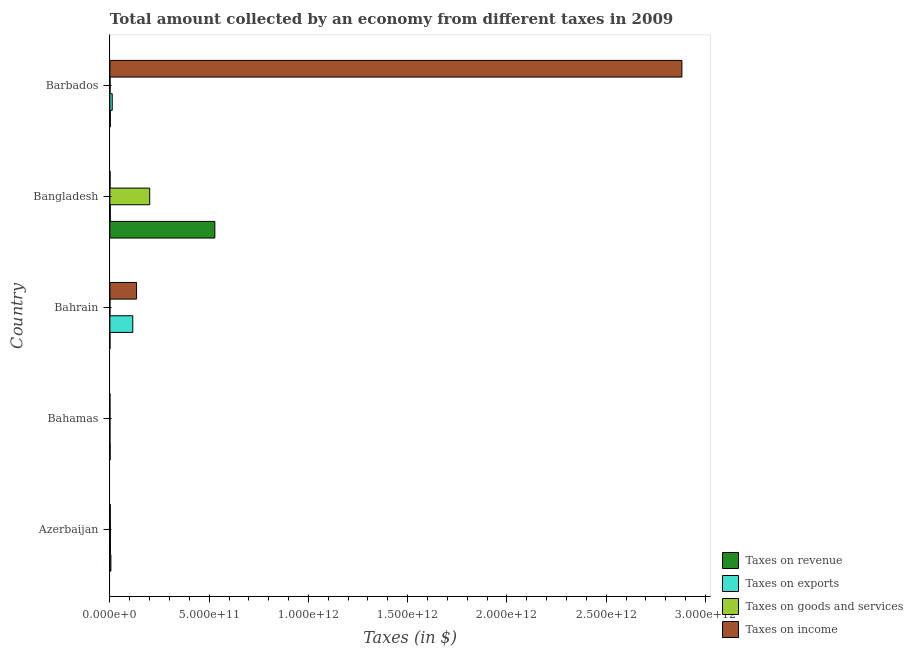Are the number of bars per tick equal to the number of legend labels?
Your answer should be very brief. Yes. What is the label of the 5th group of bars from the top?
Ensure brevity in your answer.  Azerbaijan. What is the amount collected as tax on revenue in Barbados?
Give a very brief answer. 2.21e+09. Across all countries, what is the maximum amount collected as tax on goods?
Your response must be concise. 2.01e+11. Across all countries, what is the minimum amount collected as tax on goods?
Provide a short and direct response. 2.07e+07. In which country was the amount collected as tax on income maximum?
Make the answer very short. Barbados. In which country was the amount collected as tax on exports minimum?
Your answer should be very brief. Bahamas. What is the total amount collected as tax on revenue in the graph?
Offer a very short reply. 5.37e+11. What is the difference between the amount collected as tax on exports in Bangladesh and that in Barbados?
Ensure brevity in your answer.  -9.80e+09. What is the difference between the amount collected as tax on revenue in Bahrain and the amount collected as tax on income in Barbados?
Your answer should be compact. -2.88e+12. What is the average amount collected as tax on exports per country?
Keep it short and to the point. 2.64e+1. What is the difference between the amount collected as tax on goods and amount collected as tax on revenue in Bahamas?
Provide a succinct answer. -9.43e+08. In how many countries, is the amount collected as tax on exports greater than 200000000000 $?
Provide a succinct answer. 0. What is the ratio of the amount collected as tax on exports in Bahrain to that in Barbados?
Offer a terse response. 9.75. What is the difference between the highest and the second highest amount collected as tax on revenue?
Give a very brief answer. 5.24e+11. What is the difference between the highest and the lowest amount collected as tax on revenue?
Ensure brevity in your answer.  5.29e+11. In how many countries, is the amount collected as tax on goods greater than the average amount collected as tax on goods taken over all countries?
Provide a short and direct response. 1. Is the sum of the amount collected as tax on income in Azerbaijan and Barbados greater than the maximum amount collected as tax on goods across all countries?
Offer a very short reply. Yes. What does the 2nd bar from the top in Bangladesh represents?
Make the answer very short. Taxes on goods and services. What does the 4th bar from the bottom in Barbados represents?
Your answer should be compact. Taxes on income. How many bars are there?
Provide a short and direct response. 20. Are all the bars in the graph horizontal?
Your response must be concise. Yes. What is the difference between two consecutive major ticks on the X-axis?
Your answer should be very brief. 5.00e+11. Where does the legend appear in the graph?
Your response must be concise. Bottom right. What is the title of the graph?
Provide a succinct answer. Total amount collected by an economy from different taxes in 2009. Does "Fish species" appear as one of the legend labels in the graph?
Your answer should be very brief. No. What is the label or title of the X-axis?
Ensure brevity in your answer.  Taxes (in $). What is the Taxes (in $) of Taxes on revenue in Azerbaijan?
Provide a short and direct response. 5.02e+09. What is the Taxes (in $) in Taxes on exports in Azerbaijan?
Provide a succinct answer. 2.72e+09. What is the Taxes (in $) in Taxes on goods and services in Azerbaijan?
Offer a very short reply. 2.59e+09. What is the Taxes (in $) in Taxes on income in Azerbaijan?
Provide a succinct answer. 1.92e+09. What is the Taxes (in $) of Taxes on revenue in Bahamas?
Provide a short and direct response. 1.12e+09. What is the Taxes (in $) in Taxes on exports in Bahamas?
Give a very brief answer. 7.10e+05. What is the Taxes (in $) in Taxes on goods and services in Bahamas?
Ensure brevity in your answer.  1.80e+08. What is the Taxes (in $) of Taxes on income in Bahamas?
Keep it short and to the point. 1.12e+07. What is the Taxes (in $) in Taxes on revenue in Bahrain?
Offer a very short reply. 1.18e+08. What is the Taxes (in $) in Taxes on exports in Bahrain?
Make the answer very short. 1.15e+11. What is the Taxes (in $) in Taxes on goods and services in Bahrain?
Your response must be concise. 2.07e+07. What is the Taxes (in $) in Taxes on income in Bahrain?
Make the answer very short. 1.34e+11. What is the Taxes (in $) of Taxes on revenue in Bangladesh?
Provide a succinct answer. 5.29e+11. What is the Taxes (in $) of Taxes on exports in Bangladesh?
Provide a succinct answer. 2.03e+09. What is the Taxes (in $) of Taxes on goods and services in Bangladesh?
Offer a very short reply. 2.01e+11. What is the Taxes (in $) in Taxes on income in Bangladesh?
Offer a very short reply. 8.17e+08. What is the Taxes (in $) of Taxes on revenue in Barbados?
Your response must be concise. 2.21e+09. What is the Taxes (in $) of Taxes on exports in Barbados?
Offer a very short reply. 1.18e+1. What is the Taxes (in $) in Taxes on goods and services in Barbados?
Keep it short and to the point. 9.86e+08. What is the Taxes (in $) in Taxes on income in Barbados?
Make the answer very short. 2.88e+12. Across all countries, what is the maximum Taxes (in $) in Taxes on revenue?
Your answer should be compact. 5.29e+11. Across all countries, what is the maximum Taxes (in $) in Taxes on exports?
Provide a succinct answer. 1.15e+11. Across all countries, what is the maximum Taxes (in $) of Taxes on goods and services?
Offer a terse response. 2.01e+11. Across all countries, what is the maximum Taxes (in $) in Taxes on income?
Your response must be concise. 2.88e+12. Across all countries, what is the minimum Taxes (in $) in Taxes on revenue?
Offer a very short reply. 1.18e+08. Across all countries, what is the minimum Taxes (in $) of Taxes on exports?
Offer a terse response. 7.10e+05. Across all countries, what is the minimum Taxes (in $) of Taxes on goods and services?
Offer a very short reply. 2.07e+07. Across all countries, what is the minimum Taxes (in $) in Taxes on income?
Your response must be concise. 1.12e+07. What is the total Taxes (in $) of Taxes on revenue in the graph?
Give a very brief answer. 5.37e+11. What is the total Taxes (in $) in Taxes on exports in the graph?
Provide a succinct answer. 1.32e+11. What is the total Taxes (in $) of Taxes on goods and services in the graph?
Provide a short and direct response. 2.04e+11. What is the total Taxes (in $) in Taxes on income in the graph?
Your answer should be compact. 3.02e+12. What is the difference between the Taxes (in $) of Taxes on revenue in Azerbaijan and that in Bahamas?
Give a very brief answer. 3.90e+09. What is the difference between the Taxes (in $) in Taxes on exports in Azerbaijan and that in Bahamas?
Make the answer very short. 2.72e+09. What is the difference between the Taxes (in $) in Taxes on goods and services in Azerbaijan and that in Bahamas?
Provide a short and direct response. 2.41e+09. What is the difference between the Taxes (in $) in Taxes on income in Azerbaijan and that in Bahamas?
Your answer should be very brief. 1.91e+09. What is the difference between the Taxes (in $) of Taxes on revenue in Azerbaijan and that in Bahrain?
Keep it short and to the point. 4.90e+09. What is the difference between the Taxes (in $) in Taxes on exports in Azerbaijan and that in Bahrain?
Your answer should be very brief. -1.13e+11. What is the difference between the Taxes (in $) of Taxes on goods and services in Azerbaijan and that in Bahrain?
Your answer should be compact. 2.57e+09. What is the difference between the Taxes (in $) of Taxes on income in Azerbaijan and that in Bahrain?
Offer a terse response. -1.32e+11. What is the difference between the Taxes (in $) of Taxes on revenue in Azerbaijan and that in Bangladesh?
Offer a very short reply. -5.24e+11. What is the difference between the Taxes (in $) in Taxes on exports in Azerbaijan and that in Bangladesh?
Offer a terse response. 6.92e+08. What is the difference between the Taxes (in $) of Taxes on goods and services in Azerbaijan and that in Bangladesh?
Give a very brief answer. -1.98e+11. What is the difference between the Taxes (in $) in Taxes on income in Azerbaijan and that in Bangladesh?
Your response must be concise. 1.10e+09. What is the difference between the Taxes (in $) in Taxes on revenue in Azerbaijan and that in Barbados?
Provide a succinct answer. 2.81e+09. What is the difference between the Taxes (in $) in Taxes on exports in Azerbaijan and that in Barbados?
Your answer should be very brief. -9.11e+09. What is the difference between the Taxes (in $) in Taxes on goods and services in Azerbaijan and that in Barbados?
Ensure brevity in your answer.  1.61e+09. What is the difference between the Taxes (in $) in Taxes on income in Azerbaijan and that in Barbados?
Provide a short and direct response. -2.88e+12. What is the difference between the Taxes (in $) of Taxes on revenue in Bahamas and that in Bahrain?
Your response must be concise. 1.01e+09. What is the difference between the Taxes (in $) of Taxes on exports in Bahamas and that in Bahrain?
Make the answer very short. -1.15e+11. What is the difference between the Taxes (in $) in Taxes on goods and services in Bahamas and that in Bahrain?
Ensure brevity in your answer.  1.60e+08. What is the difference between the Taxes (in $) of Taxes on income in Bahamas and that in Bahrain?
Keep it short and to the point. -1.34e+11. What is the difference between the Taxes (in $) of Taxes on revenue in Bahamas and that in Bangladesh?
Provide a succinct answer. -5.28e+11. What is the difference between the Taxes (in $) of Taxes on exports in Bahamas and that in Bangladesh?
Your answer should be compact. -2.03e+09. What is the difference between the Taxes (in $) of Taxes on goods and services in Bahamas and that in Bangladesh?
Ensure brevity in your answer.  -2.00e+11. What is the difference between the Taxes (in $) of Taxes on income in Bahamas and that in Bangladesh?
Offer a very short reply. -8.06e+08. What is the difference between the Taxes (in $) of Taxes on revenue in Bahamas and that in Barbados?
Your answer should be very brief. -1.08e+09. What is the difference between the Taxes (in $) of Taxes on exports in Bahamas and that in Barbados?
Provide a succinct answer. -1.18e+1. What is the difference between the Taxes (in $) in Taxes on goods and services in Bahamas and that in Barbados?
Give a very brief answer. -8.06e+08. What is the difference between the Taxes (in $) of Taxes on income in Bahamas and that in Barbados?
Your answer should be compact. -2.88e+12. What is the difference between the Taxes (in $) in Taxes on revenue in Bahrain and that in Bangladesh?
Offer a terse response. -5.29e+11. What is the difference between the Taxes (in $) of Taxes on exports in Bahrain and that in Bangladesh?
Your response must be concise. 1.13e+11. What is the difference between the Taxes (in $) of Taxes on goods and services in Bahrain and that in Bangladesh?
Make the answer very short. -2.01e+11. What is the difference between the Taxes (in $) of Taxes on income in Bahrain and that in Bangladesh?
Give a very brief answer. 1.34e+11. What is the difference between the Taxes (in $) in Taxes on revenue in Bahrain and that in Barbados?
Make the answer very short. -2.09e+09. What is the difference between the Taxes (in $) in Taxes on exports in Bahrain and that in Barbados?
Keep it short and to the point. 1.03e+11. What is the difference between the Taxes (in $) in Taxes on goods and services in Bahrain and that in Barbados?
Your response must be concise. -9.66e+08. What is the difference between the Taxes (in $) in Taxes on income in Bahrain and that in Barbados?
Keep it short and to the point. -2.75e+12. What is the difference between the Taxes (in $) in Taxes on revenue in Bangladesh and that in Barbados?
Your answer should be very brief. 5.26e+11. What is the difference between the Taxes (in $) in Taxes on exports in Bangladesh and that in Barbados?
Provide a short and direct response. -9.80e+09. What is the difference between the Taxes (in $) of Taxes on goods and services in Bangladesh and that in Barbados?
Make the answer very short. 2.00e+11. What is the difference between the Taxes (in $) of Taxes on income in Bangladesh and that in Barbados?
Your response must be concise. -2.88e+12. What is the difference between the Taxes (in $) of Taxes on revenue in Azerbaijan and the Taxes (in $) of Taxes on exports in Bahamas?
Make the answer very short. 5.02e+09. What is the difference between the Taxes (in $) of Taxes on revenue in Azerbaijan and the Taxes (in $) of Taxes on goods and services in Bahamas?
Offer a terse response. 4.84e+09. What is the difference between the Taxes (in $) of Taxes on revenue in Azerbaijan and the Taxes (in $) of Taxes on income in Bahamas?
Offer a terse response. 5.01e+09. What is the difference between the Taxes (in $) of Taxes on exports in Azerbaijan and the Taxes (in $) of Taxes on goods and services in Bahamas?
Provide a succinct answer. 2.54e+09. What is the difference between the Taxes (in $) of Taxes on exports in Azerbaijan and the Taxes (in $) of Taxes on income in Bahamas?
Make the answer very short. 2.71e+09. What is the difference between the Taxes (in $) in Taxes on goods and services in Azerbaijan and the Taxes (in $) in Taxes on income in Bahamas?
Ensure brevity in your answer.  2.58e+09. What is the difference between the Taxes (in $) of Taxes on revenue in Azerbaijan and the Taxes (in $) of Taxes on exports in Bahrain?
Your response must be concise. -1.10e+11. What is the difference between the Taxes (in $) of Taxes on revenue in Azerbaijan and the Taxes (in $) of Taxes on goods and services in Bahrain?
Offer a terse response. 5.00e+09. What is the difference between the Taxes (in $) in Taxes on revenue in Azerbaijan and the Taxes (in $) in Taxes on income in Bahrain?
Your answer should be compact. -1.29e+11. What is the difference between the Taxes (in $) of Taxes on exports in Azerbaijan and the Taxes (in $) of Taxes on goods and services in Bahrain?
Your answer should be compact. 2.70e+09. What is the difference between the Taxes (in $) in Taxes on exports in Azerbaijan and the Taxes (in $) in Taxes on income in Bahrain?
Your response must be concise. -1.32e+11. What is the difference between the Taxes (in $) in Taxes on goods and services in Azerbaijan and the Taxes (in $) in Taxes on income in Bahrain?
Your answer should be compact. -1.32e+11. What is the difference between the Taxes (in $) of Taxes on revenue in Azerbaijan and the Taxes (in $) of Taxes on exports in Bangladesh?
Provide a short and direct response. 2.99e+09. What is the difference between the Taxes (in $) of Taxes on revenue in Azerbaijan and the Taxes (in $) of Taxes on goods and services in Bangladesh?
Provide a succinct answer. -1.96e+11. What is the difference between the Taxes (in $) of Taxes on revenue in Azerbaijan and the Taxes (in $) of Taxes on income in Bangladesh?
Provide a short and direct response. 4.21e+09. What is the difference between the Taxes (in $) of Taxes on exports in Azerbaijan and the Taxes (in $) of Taxes on goods and services in Bangladesh?
Provide a short and direct response. -1.98e+11. What is the difference between the Taxes (in $) in Taxes on exports in Azerbaijan and the Taxes (in $) in Taxes on income in Bangladesh?
Provide a short and direct response. 1.91e+09. What is the difference between the Taxes (in $) in Taxes on goods and services in Azerbaijan and the Taxes (in $) in Taxes on income in Bangladesh?
Provide a succinct answer. 1.78e+09. What is the difference between the Taxes (in $) in Taxes on revenue in Azerbaijan and the Taxes (in $) in Taxes on exports in Barbados?
Provide a short and direct response. -6.81e+09. What is the difference between the Taxes (in $) in Taxes on revenue in Azerbaijan and the Taxes (in $) in Taxes on goods and services in Barbados?
Provide a short and direct response. 4.04e+09. What is the difference between the Taxes (in $) of Taxes on revenue in Azerbaijan and the Taxes (in $) of Taxes on income in Barbados?
Make the answer very short. -2.88e+12. What is the difference between the Taxes (in $) in Taxes on exports in Azerbaijan and the Taxes (in $) in Taxes on goods and services in Barbados?
Provide a succinct answer. 1.74e+09. What is the difference between the Taxes (in $) of Taxes on exports in Azerbaijan and the Taxes (in $) of Taxes on income in Barbados?
Your answer should be very brief. -2.88e+12. What is the difference between the Taxes (in $) in Taxes on goods and services in Azerbaijan and the Taxes (in $) in Taxes on income in Barbados?
Make the answer very short. -2.88e+12. What is the difference between the Taxes (in $) of Taxes on revenue in Bahamas and the Taxes (in $) of Taxes on exports in Bahrain?
Give a very brief answer. -1.14e+11. What is the difference between the Taxes (in $) of Taxes on revenue in Bahamas and the Taxes (in $) of Taxes on goods and services in Bahrain?
Your response must be concise. 1.10e+09. What is the difference between the Taxes (in $) in Taxes on revenue in Bahamas and the Taxes (in $) in Taxes on income in Bahrain?
Give a very brief answer. -1.33e+11. What is the difference between the Taxes (in $) in Taxes on exports in Bahamas and the Taxes (in $) in Taxes on goods and services in Bahrain?
Offer a terse response. -2.00e+07. What is the difference between the Taxes (in $) in Taxes on exports in Bahamas and the Taxes (in $) in Taxes on income in Bahrain?
Your answer should be very brief. -1.34e+11. What is the difference between the Taxes (in $) of Taxes on goods and services in Bahamas and the Taxes (in $) of Taxes on income in Bahrain?
Offer a terse response. -1.34e+11. What is the difference between the Taxes (in $) in Taxes on revenue in Bahamas and the Taxes (in $) in Taxes on exports in Bangladesh?
Offer a very short reply. -9.07e+08. What is the difference between the Taxes (in $) in Taxes on revenue in Bahamas and the Taxes (in $) in Taxes on goods and services in Bangladesh?
Provide a succinct answer. -1.99e+11. What is the difference between the Taxes (in $) in Taxes on revenue in Bahamas and the Taxes (in $) in Taxes on income in Bangladesh?
Your answer should be compact. 3.06e+08. What is the difference between the Taxes (in $) in Taxes on exports in Bahamas and the Taxes (in $) in Taxes on goods and services in Bangladesh?
Offer a very short reply. -2.01e+11. What is the difference between the Taxes (in $) in Taxes on exports in Bahamas and the Taxes (in $) in Taxes on income in Bangladesh?
Give a very brief answer. -8.16e+08. What is the difference between the Taxes (in $) of Taxes on goods and services in Bahamas and the Taxes (in $) of Taxes on income in Bangladesh?
Your answer should be compact. -6.36e+08. What is the difference between the Taxes (in $) in Taxes on revenue in Bahamas and the Taxes (in $) in Taxes on exports in Barbados?
Keep it short and to the point. -1.07e+1. What is the difference between the Taxes (in $) in Taxes on revenue in Bahamas and the Taxes (in $) in Taxes on goods and services in Barbados?
Your response must be concise. 1.37e+08. What is the difference between the Taxes (in $) in Taxes on revenue in Bahamas and the Taxes (in $) in Taxes on income in Barbados?
Your answer should be compact. -2.88e+12. What is the difference between the Taxes (in $) of Taxes on exports in Bahamas and the Taxes (in $) of Taxes on goods and services in Barbados?
Provide a succinct answer. -9.86e+08. What is the difference between the Taxes (in $) in Taxes on exports in Bahamas and the Taxes (in $) in Taxes on income in Barbados?
Ensure brevity in your answer.  -2.88e+12. What is the difference between the Taxes (in $) in Taxes on goods and services in Bahamas and the Taxes (in $) in Taxes on income in Barbados?
Your answer should be very brief. -2.88e+12. What is the difference between the Taxes (in $) in Taxes on revenue in Bahrain and the Taxes (in $) in Taxes on exports in Bangladesh?
Keep it short and to the point. -1.91e+09. What is the difference between the Taxes (in $) in Taxes on revenue in Bahrain and the Taxes (in $) in Taxes on goods and services in Bangladesh?
Offer a very short reply. -2.00e+11. What is the difference between the Taxes (in $) of Taxes on revenue in Bahrain and the Taxes (in $) of Taxes on income in Bangladesh?
Provide a short and direct response. -6.99e+08. What is the difference between the Taxes (in $) of Taxes on exports in Bahrain and the Taxes (in $) of Taxes on goods and services in Bangladesh?
Your response must be concise. -8.52e+1. What is the difference between the Taxes (in $) of Taxes on exports in Bahrain and the Taxes (in $) of Taxes on income in Bangladesh?
Your answer should be very brief. 1.15e+11. What is the difference between the Taxes (in $) of Taxes on goods and services in Bahrain and the Taxes (in $) of Taxes on income in Bangladesh?
Your answer should be compact. -7.96e+08. What is the difference between the Taxes (in $) in Taxes on revenue in Bahrain and the Taxes (in $) in Taxes on exports in Barbados?
Make the answer very short. -1.17e+1. What is the difference between the Taxes (in $) of Taxes on revenue in Bahrain and the Taxes (in $) of Taxes on goods and services in Barbados?
Your answer should be compact. -8.69e+08. What is the difference between the Taxes (in $) in Taxes on revenue in Bahrain and the Taxes (in $) in Taxes on income in Barbados?
Offer a terse response. -2.88e+12. What is the difference between the Taxes (in $) in Taxes on exports in Bahrain and the Taxes (in $) in Taxes on goods and services in Barbados?
Your answer should be compact. 1.14e+11. What is the difference between the Taxes (in $) of Taxes on exports in Bahrain and the Taxes (in $) of Taxes on income in Barbados?
Keep it short and to the point. -2.77e+12. What is the difference between the Taxes (in $) in Taxes on goods and services in Bahrain and the Taxes (in $) in Taxes on income in Barbados?
Ensure brevity in your answer.  -2.88e+12. What is the difference between the Taxes (in $) of Taxes on revenue in Bangladesh and the Taxes (in $) of Taxes on exports in Barbados?
Make the answer very short. 5.17e+11. What is the difference between the Taxes (in $) of Taxes on revenue in Bangladesh and the Taxes (in $) of Taxes on goods and services in Barbados?
Your answer should be very brief. 5.28e+11. What is the difference between the Taxes (in $) of Taxes on revenue in Bangladesh and the Taxes (in $) of Taxes on income in Barbados?
Provide a succinct answer. -2.35e+12. What is the difference between the Taxes (in $) in Taxes on exports in Bangladesh and the Taxes (in $) in Taxes on goods and services in Barbados?
Ensure brevity in your answer.  1.04e+09. What is the difference between the Taxes (in $) in Taxes on exports in Bangladesh and the Taxes (in $) in Taxes on income in Barbados?
Your answer should be compact. -2.88e+12. What is the difference between the Taxes (in $) of Taxes on goods and services in Bangladesh and the Taxes (in $) of Taxes on income in Barbados?
Provide a succinct answer. -2.68e+12. What is the average Taxes (in $) in Taxes on revenue per country?
Give a very brief answer. 1.07e+11. What is the average Taxes (in $) of Taxes on exports per country?
Give a very brief answer. 2.64e+1. What is the average Taxes (in $) of Taxes on goods and services per country?
Provide a short and direct response. 4.09e+1. What is the average Taxes (in $) in Taxes on income per country?
Make the answer very short. 6.04e+11. What is the difference between the Taxes (in $) of Taxes on revenue and Taxes (in $) of Taxes on exports in Azerbaijan?
Give a very brief answer. 2.30e+09. What is the difference between the Taxes (in $) of Taxes on revenue and Taxes (in $) of Taxes on goods and services in Azerbaijan?
Your answer should be very brief. 2.43e+09. What is the difference between the Taxes (in $) in Taxes on revenue and Taxes (in $) in Taxes on income in Azerbaijan?
Your answer should be compact. 3.10e+09. What is the difference between the Taxes (in $) of Taxes on exports and Taxes (in $) of Taxes on goods and services in Azerbaijan?
Ensure brevity in your answer.  1.29e+08. What is the difference between the Taxes (in $) of Taxes on exports and Taxes (in $) of Taxes on income in Azerbaijan?
Offer a very short reply. 8.01e+08. What is the difference between the Taxes (in $) in Taxes on goods and services and Taxes (in $) in Taxes on income in Azerbaijan?
Your response must be concise. 6.72e+08. What is the difference between the Taxes (in $) of Taxes on revenue and Taxes (in $) of Taxes on exports in Bahamas?
Offer a very short reply. 1.12e+09. What is the difference between the Taxes (in $) in Taxes on revenue and Taxes (in $) in Taxes on goods and services in Bahamas?
Your answer should be compact. 9.43e+08. What is the difference between the Taxes (in $) in Taxes on revenue and Taxes (in $) in Taxes on income in Bahamas?
Give a very brief answer. 1.11e+09. What is the difference between the Taxes (in $) in Taxes on exports and Taxes (in $) in Taxes on goods and services in Bahamas?
Provide a succinct answer. -1.80e+08. What is the difference between the Taxes (in $) of Taxes on exports and Taxes (in $) of Taxes on income in Bahamas?
Your answer should be very brief. -1.05e+07. What is the difference between the Taxes (in $) in Taxes on goods and services and Taxes (in $) in Taxes on income in Bahamas?
Provide a short and direct response. 1.69e+08. What is the difference between the Taxes (in $) in Taxes on revenue and Taxes (in $) in Taxes on exports in Bahrain?
Offer a terse response. -1.15e+11. What is the difference between the Taxes (in $) in Taxes on revenue and Taxes (in $) in Taxes on goods and services in Bahrain?
Keep it short and to the point. 9.69e+07. What is the difference between the Taxes (in $) of Taxes on revenue and Taxes (in $) of Taxes on income in Bahrain?
Provide a succinct answer. -1.34e+11. What is the difference between the Taxes (in $) in Taxes on exports and Taxes (in $) in Taxes on goods and services in Bahrain?
Keep it short and to the point. 1.15e+11. What is the difference between the Taxes (in $) of Taxes on exports and Taxes (in $) of Taxes on income in Bahrain?
Provide a short and direct response. -1.90e+1. What is the difference between the Taxes (in $) in Taxes on goods and services and Taxes (in $) in Taxes on income in Bahrain?
Provide a short and direct response. -1.34e+11. What is the difference between the Taxes (in $) in Taxes on revenue and Taxes (in $) in Taxes on exports in Bangladesh?
Provide a succinct answer. 5.27e+11. What is the difference between the Taxes (in $) in Taxes on revenue and Taxes (in $) in Taxes on goods and services in Bangladesh?
Offer a terse response. 3.28e+11. What is the difference between the Taxes (in $) of Taxes on revenue and Taxes (in $) of Taxes on income in Bangladesh?
Provide a succinct answer. 5.28e+11. What is the difference between the Taxes (in $) of Taxes on exports and Taxes (in $) of Taxes on goods and services in Bangladesh?
Your response must be concise. -1.99e+11. What is the difference between the Taxes (in $) of Taxes on exports and Taxes (in $) of Taxes on income in Bangladesh?
Make the answer very short. 1.21e+09. What is the difference between the Taxes (in $) of Taxes on goods and services and Taxes (in $) of Taxes on income in Bangladesh?
Offer a terse response. 2.00e+11. What is the difference between the Taxes (in $) of Taxes on revenue and Taxes (in $) of Taxes on exports in Barbados?
Offer a terse response. -9.63e+09. What is the difference between the Taxes (in $) in Taxes on revenue and Taxes (in $) in Taxes on goods and services in Barbados?
Your answer should be very brief. 1.22e+09. What is the difference between the Taxes (in $) in Taxes on revenue and Taxes (in $) in Taxes on income in Barbados?
Give a very brief answer. -2.88e+12. What is the difference between the Taxes (in $) in Taxes on exports and Taxes (in $) in Taxes on goods and services in Barbados?
Offer a very short reply. 1.08e+1. What is the difference between the Taxes (in $) of Taxes on exports and Taxes (in $) of Taxes on income in Barbados?
Give a very brief answer. -2.87e+12. What is the difference between the Taxes (in $) of Taxes on goods and services and Taxes (in $) of Taxes on income in Barbados?
Offer a very short reply. -2.88e+12. What is the ratio of the Taxes (in $) of Taxes on revenue in Azerbaijan to that in Bahamas?
Your response must be concise. 4.47. What is the ratio of the Taxes (in $) in Taxes on exports in Azerbaijan to that in Bahamas?
Give a very brief answer. 3833.75. What is the ratio of the Taxes (in $) in Taxes on goods and services in Azerbaijan to that in Bahamas?
Give a very brief answer. 14.37. What is the ratio of the Taxes (in $) of Taxes on income in Azerbaijan to that in Bahamas?
Offer a terse response. 171.78. What is the ratio of the Taxes (in $) in Taxes on revenue in Azerbaijan to that in Bahrain?
Offer a very short reply. 42.72. What is the ratio of the Taxes (in $) in Taxes on exports in Azerbaijan to that in Bahrain?
Keep it short and to the point. 0.02. What is the ratio of the Taxes (in $) in Taxes on goods and services in Azerbaijan to that in Bahrain?
Make the answer very short. 125.27. What is the ratio of the Taxes (in $) in Taxes on income in Azerbaijan to that in Bahrain?
Offer a terse response. 0.01. What is the ratio of the Taxes (in $) of Taxes on revenue in Azerbaijan to that in Bangladesh?
Keep it short and to the point. 0.01. What is the ratio of the Taxes (in $) in Taxes on exports in Azerbaijan to that in Bangladesh?
Your response must be concise. 1.34. What is the ratio of the Taxes (in $) of Taxes on goods and services in Azerbaijan to that in Bangladesh?
Offer a very short reply. 0.01. What is the ratio of the Taxes (in $) in Taxes on income in Azerbaijan to that in Bangladesh?
Offer a terse response. 2.35. What is the ratio of the Taxes (in $) in Taxes on revenue in Azerbaijan to that in Barbados?
Make the answer very short. 2.28. What is the ratio of the Taxes (in $) in Taxes on exports in Azerbaijan to that in Barbados?
Keep it short and to the point. 0.23. What is the ratio of the Taxes (in $) of Taxes on goods and services in Azerbaijan to that in Barbados?
Give a very brief answer. 2.63. What is the ratio of the Taxes (in $) of Taxes on income in Azerbaijan to that in Barbados?
Make the answer very short. 0. What is the ratio of the Taxes (in $) in Taxes on revenue in Bahamas to that in Bahrain?
Offer a very short reply. 9.55. What is the ratio of the Taxes (in $) in Taxes on exports in Bahamas to that in Bahrain?
Provide a succinct answer. 0. What is the ratio of the Taxes (in $) in Taxes on goods and services in Bahamas to that in Bahrain?
Offer a very short reply. 8.72. What is the ratio of the Taxes (in $) in Taxes on income in Bahamas to that in Bahrain?
Provide a succinct answer. 0. What is the ratio of the Taxes (in $) in Taxes on revenue in Bahamas to that in Bangladesh?
Offer a terse response. 0. What is the ratio of the Taxes (in $) in Taxes on goods and services in Bahamas to that in Bangladesh?
Give a very brief answer. 0. What is the ratio of the Taxes (in $) in Taxes on income in Bahamas to that in Bangladesh?
Your answer should be compact. 0.01. What is the ratio of the Taxes (in $) in Taxes on revenue in Bahamas to that in Barbados?
Your answer should be compact. 0.51. What is the ratio of the Taxes (in $) in Taxes on exports in Bahamas to that in Barbados?
Your response must be concise. 0. What is the ratio of the Taxes (in $) in Taxes on goods and services in Bahamas to that in Barbados?
Your response must be concise. 0.18. What is the ratio of the Taxes (in $) in Taxes on income in Bahamas to that in Barbados?
Offer a terse response. 0. What is the ratio of the Taxes (in $) in Taxes on revenue in Bahrain to that in Bangladesh?
Your answer should be very brief. 0. What is the ratio of the Taxes (in $) of Taxes on exports in Bahrain to that in Bangladesh?
Ensure brevity in your answer.  56.81. What is the ratio of the Taxes (in $) of Taxes on goods and services in Bahrain to that in Bangladesh?
Offer a very short reply. 0. What is the ratio of the Taxes (in $) in Taxes on income in Bahrain to that in Bangladesh?
Ensure brevity in your answer.  164.46. What is the ratio of the Taxes (in $) of Taxes on revenue in Bahrain to that in Barbados?
Keep it short and to the point. 0.05. What is the ratio of the Taxes (in $) in Taxes on exports in Bahrain to that in Barbados?
Provide a succinct answer. 9.75. What is the ratio of the Taxes (in $) of Taxes on goods and services in Bahrain to that in Barbados?
Provide a short and direct response. 0.02. What is the ratio of the Taxes (in $) of Taxes on income in Bahrain to that in Barbados?
Keep it short and to the point. 0.05. What is the ratio of the Taxes (in $) in Taxes on revenue in Bangladesh to that in Barbados?
Provide a short and direct response. 239.52. What is the ratio of the Taxes (in $) of Taxes on exports in Bangladesh to that in Barbados?
Your answer should be compact. 0.17. What is the ratio of the Taxes (in $) of Taxes on goods and services in Bangladesh to that in Barbados?
Ensure brevity in your answer.  203.3. What is the difference between the highest and the second highest Taxes (in $) in Taxes on revenue?
Keep it short and to the point. 5.24e+11. What is the difference between the highest and the second highest Taxes (in $) in Taxes on exports?
Ensure brevity in your answer.  1.03e+11. What is the difference between the highest and the second highest Taxes (in $) of Taxes on goods and services?
Provide a succinct answer. 1.98e+11. What is the difference between the highest and the second highest Taxes (in $) in Taxes on income?
Your answer should be compact. 2.75e+12. What is the difference between the highest and the lowest Taxes (in $) in Taxes on revenue?
Offer a terse response. 5.29e+11. What is the difference between the highest and the lowest Taxes (in $) in Taxes on exports?
Ensure brevity in your answer.  1.15e+11. What is the difference between the highest and the lowest Taxes (in $) of Taxes on goods and services?
Your response must be concise. 2.01e+11. What is the difference between the highest and the lowest Taxes (in $) in Taxes on income?
Provide a succinct answer. 2.88e+12. 